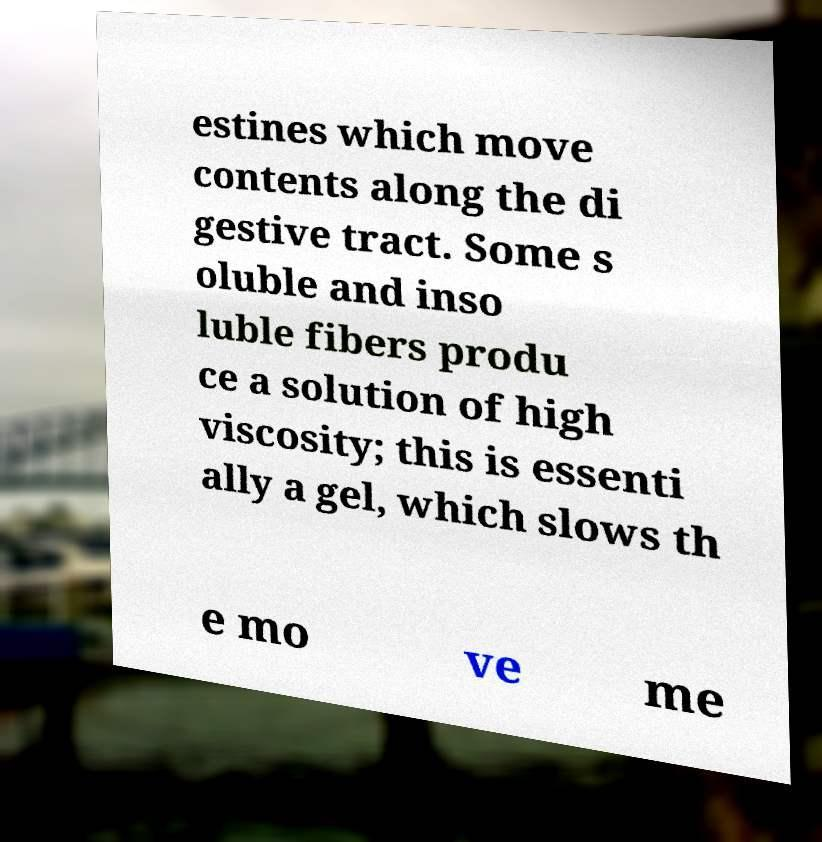Could you assist in decoding the text presented in this image and type it out clearly? estines which move contents along the di gestive tract. Some s oluble and inso luble fibers produ ce a solution of high viscosity; this is essenti ally a gel, which slows th e mo ve me 